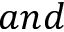<formula> <loc_0><loc_0><loc_500><loc_500>a n d</formula> 